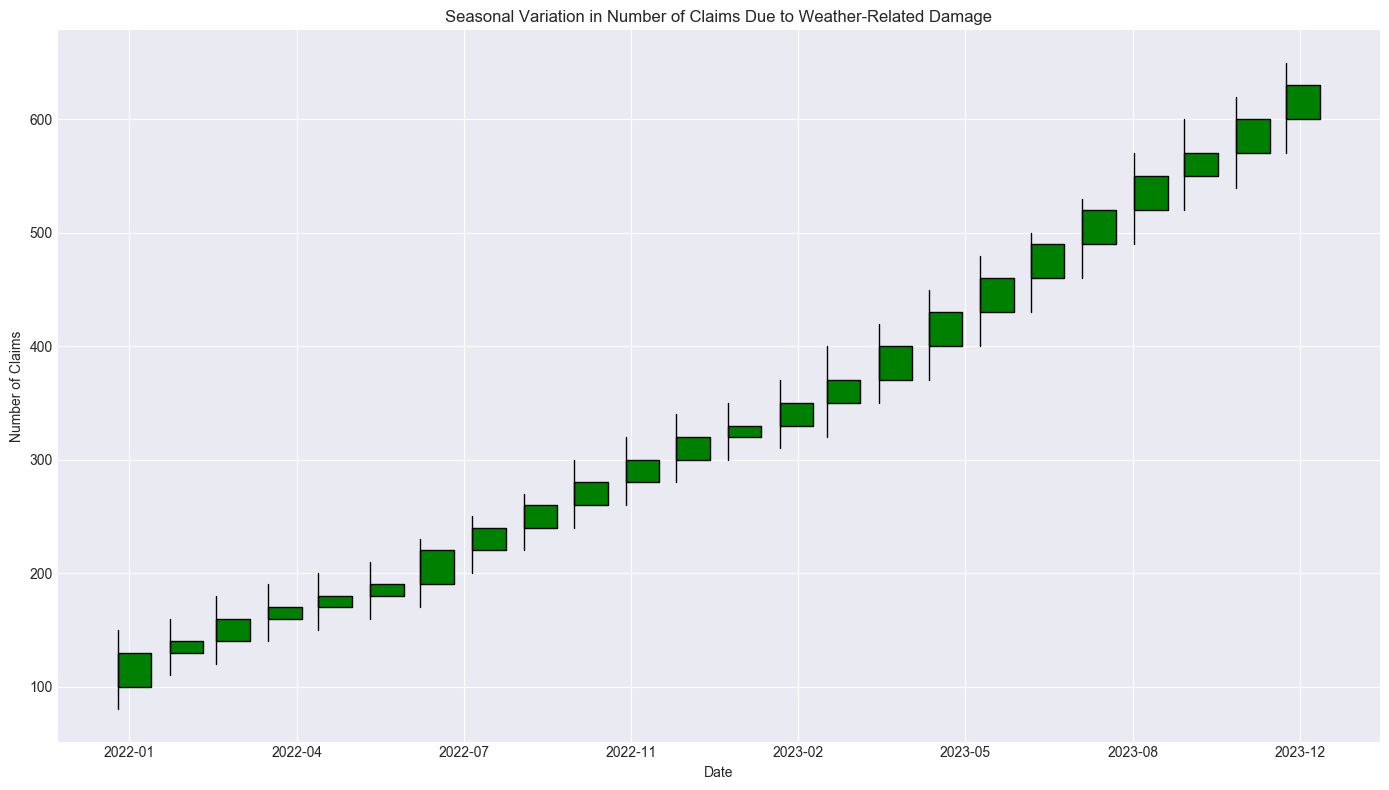Which month shows the highest number of claims? To find the month with the highest number of claims, look for the candlestick with the highest 'High' value. The month with the highest 'High' value corresponds to October 2023.
Answer: October 2023 How does the number of claims in July 2023 compare to January 2023? To compare the number of claims, check the 'Close' values for July 2023 and January 2023. July 2023 has a 'Close' value of 490, and January 2023 has a 'Close' value of 330. July 2023 has higher claims compared to January 2023.
Answer: July 2023 has higher claims What is the average number of claims in January 2022 and January 2023? Calculate the average of the 'Close' values for January 2022 and January 2023. January 2022 has 130 claims, and January 2023 has 330 claims. The average is (130 + 330) / 2 = 230.
Answer: 230 Which month exhibits the largest difference between the highest and lowest number of claims? To find this month, subtract the 'Low' value from the 'High' value for each month and identify the largest difference. August 2023 has the largest difference (530 - 460 = 70).
Answer: August 2023 In which months did the number of claims decrease compared to the previous month? To identify the months with a decrease in claims, compare the 'Close' values for consecutive months. Claims decrease when the 'Close' value is lower than the previous month's 'Close'. No month shows a decrease; all months either maintain or increase the number of claims.
Answer: None Are there more months where claims increased than those where claims remained the same or decreased? Count the instances where the 'Close' of a month is higher, lower, or equal to the previous month's 'Close' value. Since all months show an increase, there are more months with increased claims.
Answer: Yes What is the trend in the number of claims from January 2022 to December 2023? Observe the overall movement of the candlesticks from January 2022 to December 2023. The trend shows a steady increase in claims each month.
Answer: Steady increase What was the percent increase in claims from December 2022 to December 2023? Calculate the percent increase: ((Close in December 2023 - Close in December 2022) / Close in December 2022) * 100. The values are (630 - 320) / 320 = 310 / 320 = 0.96875 * 100 ≈ 96.88%.
Answer: 96.88% Did the number of claims ever stabilize across two consecutive months? Look for consecutive months where the 'Close' values are equal, indicating stabilization. There is no instance where claims remained the same across consecutive months.
Answer: No 